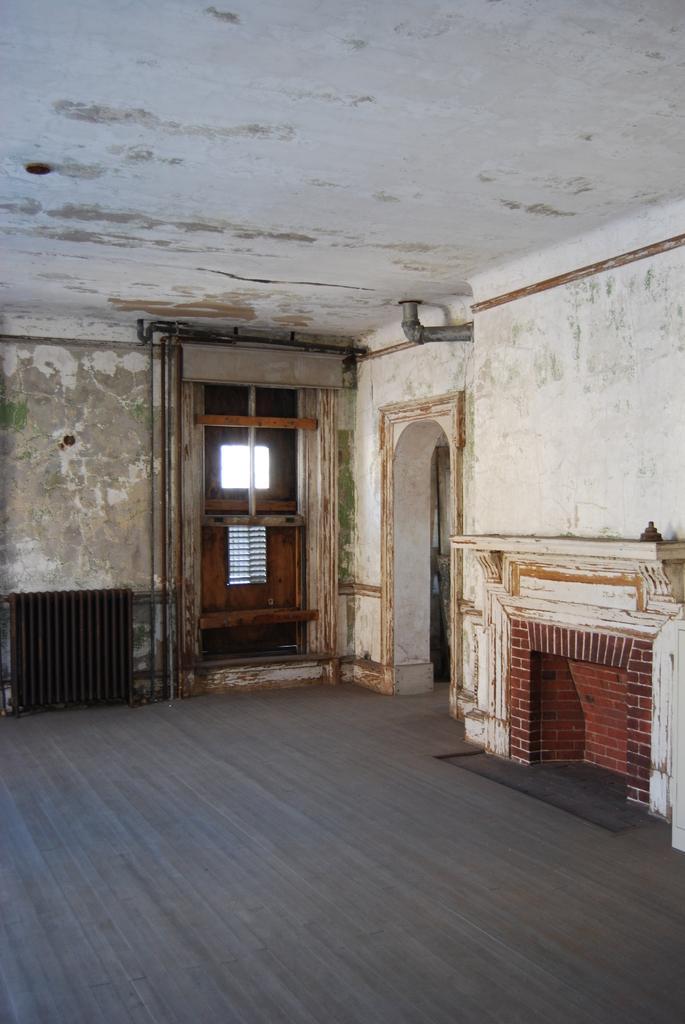Describe this image in one or two sentences. In this picture there is interior of a building and there is a door in the background and there is a fire place in the right corner. 